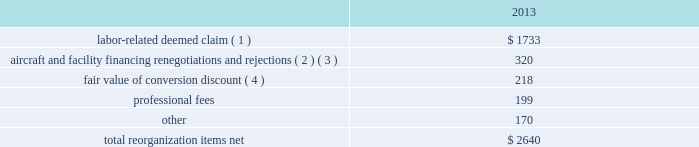Table of contents the following discussion of nonoperating income and expense excludes the results of us airways in order to provide a more meaningful year-over-year comparison .
Interest expense , net of capitalized interest decreased $ 129 million in 2014 from 2013 primarily due to a $ 63 million decrease in special charges recognized year-over-year as further described below , as well as refinancing activities that resulted in $ 65 million less interest expense recognized in 2014 .
( 1 ) in 2014 , american recognized $ 29 million of special charges relating to non-cash interest accretion on bankruptcy settlement obligations .
In 2013 , american recognized $ 48 million of special charges relating to post-petition interest expense on unsecured obligations pursuant to the plan and penalty interest related to american 2019s 10.5% ( 10.5 % ) secured notes and 7.50% ( 7.50 % ) senior secured notes .
In addition , in 2013 american recorded special charges of $ 44 million for debt extinguishment costs incurred as a result of the repayment of certain aircraft secured indebtedness , including cash interest charges and non-cash write offs of unamortized debt issuance costs .
( 2 ) as a result of the 2013 refinancing activities and the early extinguishment of american 2019s 7.50% ( 7.50 % ) senior secured notes in 2014 , american incurred $ 65 million less interest expense in 2014 as compared to 2013 .
Other nonoperating expense , net in 2014 consisted of $ 92 million of net foreign currency losses , including a $ 43 million special charge for venezuelan foreign currency losses , and $ 48 million of early debt extinguishment costs related to the prepayment of american 2019s 7.50% ( 7.50 % ) senior secured notes and other indebtedness .
The foreign currency losses were driven primarily by the strengthening of the u.s .
Dollar relative to other currencies during 2014 , principally in the latin american market , including a 48% ( 48 % ) decrease in the value of the venezuelan bolivar and a 14% ( 14 % ) decrease in the value of the brazilian real .
Other nonoperating expense , net in 2013 consisted principally of net foreign currency losses of $ 55 million and early debt extinguishment charges of $ 29 million .
Reorganization items , net reorganization items refer to revenues , expenses ( including professional fees ) , realized gains and losses and provisions for losses that are realized or incurred as a direct result of the chapter 11 cases .
The table summarizes the components included in reorganization items , net on american 2019s consolidated statement of operations for the year ended december 31 , 2013 ( in millions ) : .
( 1 ) in exchange for employees 2019 contributions to the successful reorganization , including agreeing to reductions in pay and benefits , american agreed in the plan to provide each employee group a deemed claim , which was used to provide a distribution of a portion of the equity of the reorganized entity to those employees .
Each employee group received a deemed claim amount based upon a portion of the value of cost savings provided by that group through reductions to pay and benefits as well as through certain work rule changes .
The total value of this deemed claim was approximately $ 1.7 billion .
( 2 ) amounts include allowed claims ( claims approved by the bankruptcy court ) and estimated allowed claims relating to ( i ) the rejection or modification of financings related to aircraft and ( ii ) entry of orders treated as unsecured claims with respect to facility agreements supporting certain issuances of special facility revenue .
What percentage of total 2013 reorganization items consisted of professional fees? 
Computations: (199 / 2640)
Answer: 0.07538. 